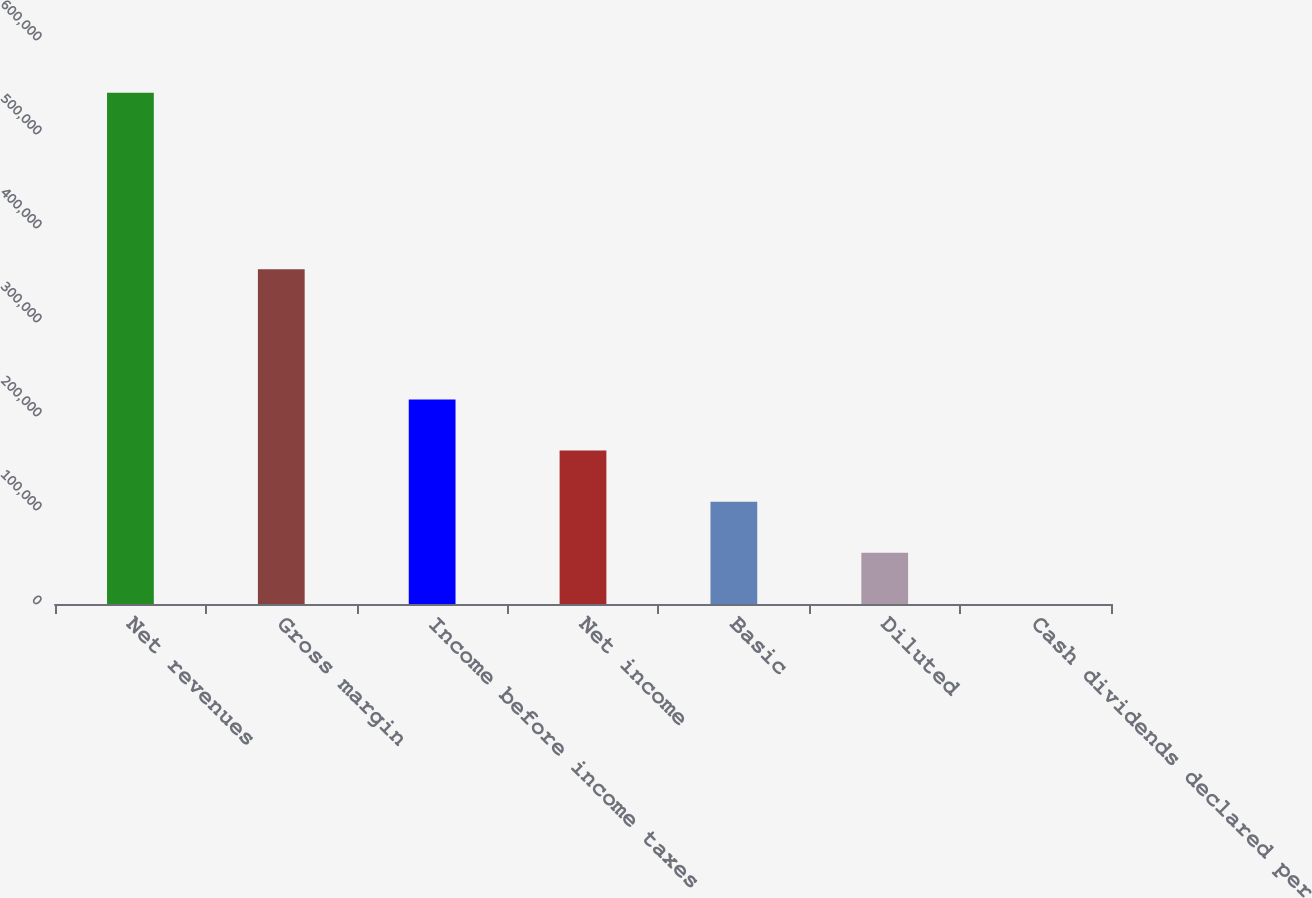Convert chart. <chart><loc_0><loc_0><loc_500><loc_500><bar_chart><fcel>Net revenues<fcel>Gross margin<fcel>Income before income taxes<fcel>Net income<fcel>Basic<fcel>Diluted<fcel>Cash dividends declared per<nl><fcel>543933<fcel>356220<fcel>217573<fcel>163180<fcel>108787<fcel>54393.5<fcel>0.22<nl></chart> 